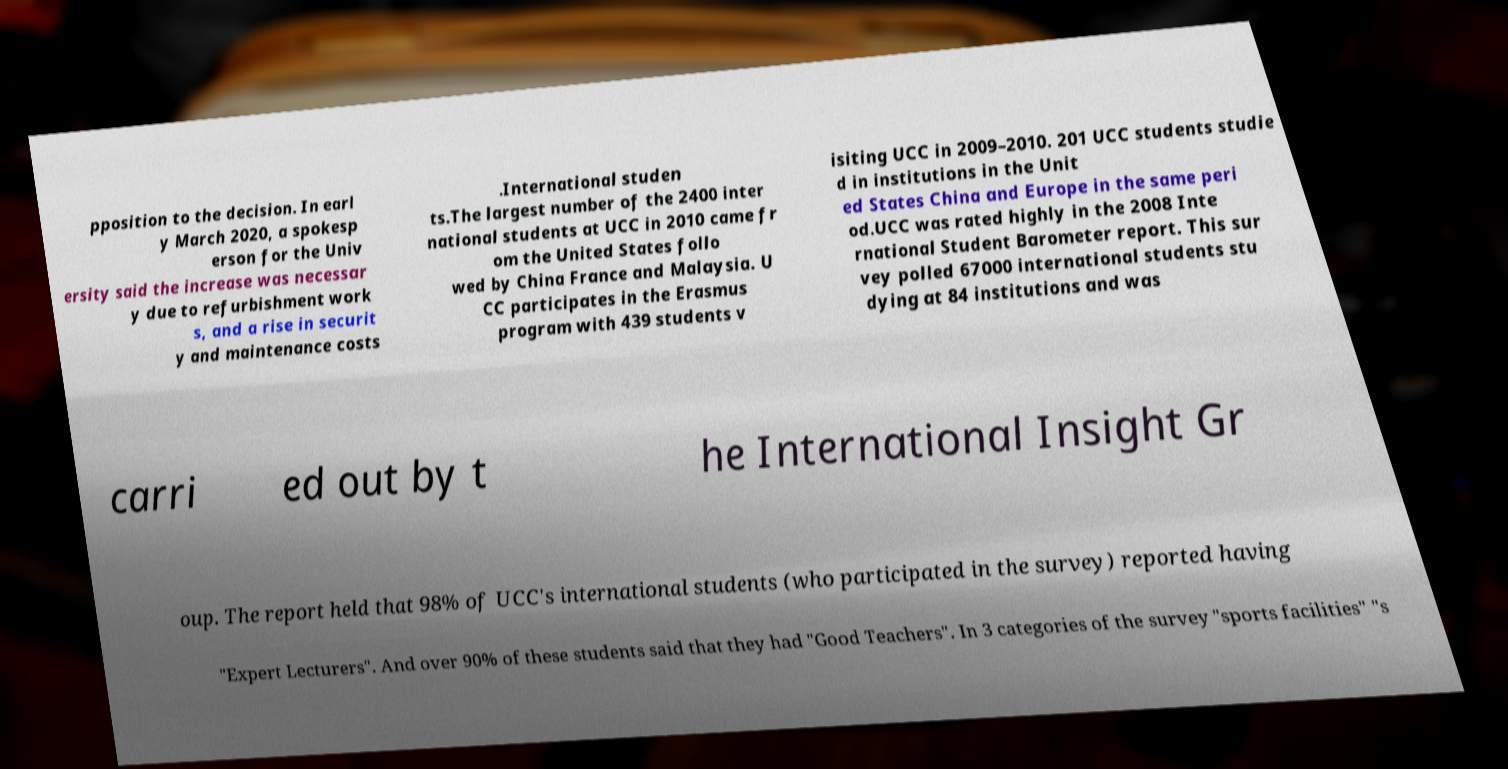Could you extract and type out the text from this image? pposition to the decision. In earl y March 2020, a spokesp erson for the Univ ersity said the increase was necessar y due to refurbishment work s, and a rise in securit y and maintenance costs .International studen ts.The largest number of the 2400 inter national students at UCC in 2010 came fr om the United States follo wed by China France and Malaysia. U CC participates in the Erasmus program with 439 students v isiting UCC in 2009–2010. 201 UCC students studie d in institutions in the Unit ed States China and Europe in the same peri od.UCC was rated highly in the 2008 Inte rnational Student Barometer report. This sur vey polled 67000 international students stu dying at 84 institutions and was carri ed out by t he International Insight Gr oup. The report held that 98% of UCC's international students (who participated in the survey) reported having "Expert Lecturers". And over 90% of these students said that they had "Good Teachers". In 3 categories of the survey "sports facilities" "s 